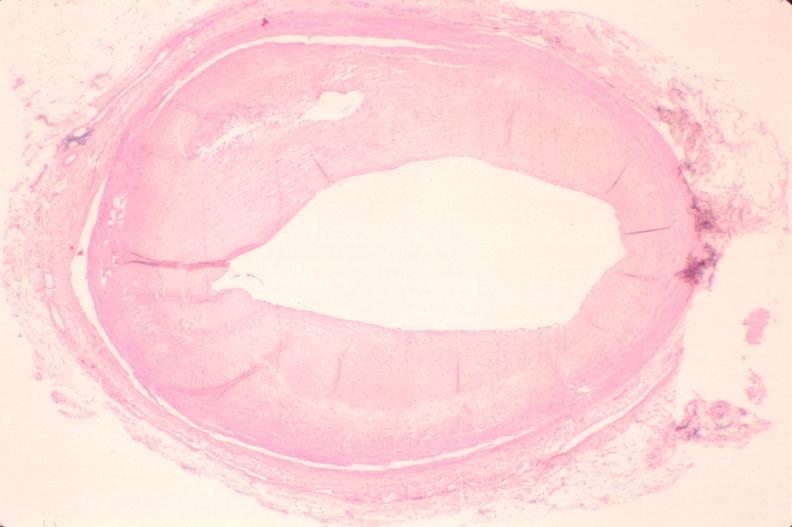what is present?
Answer the question using a single word or phrase. Vasculature 